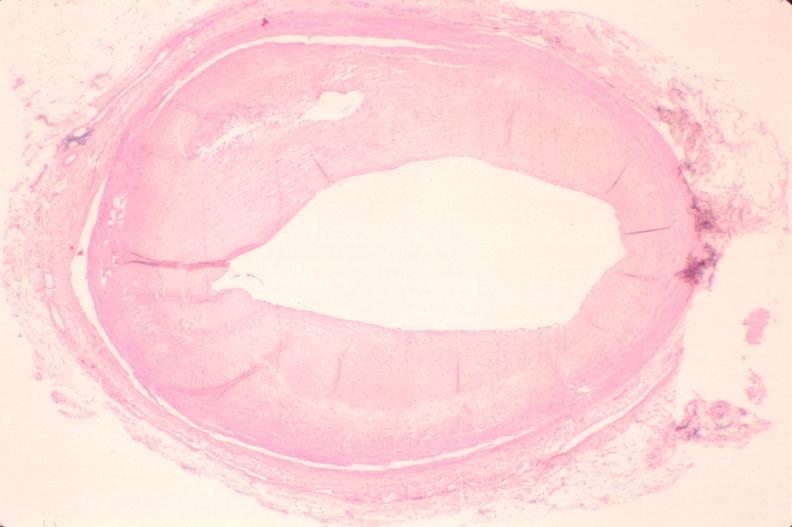what is present?
Answer the question using a single word or phrase. Vasculature 